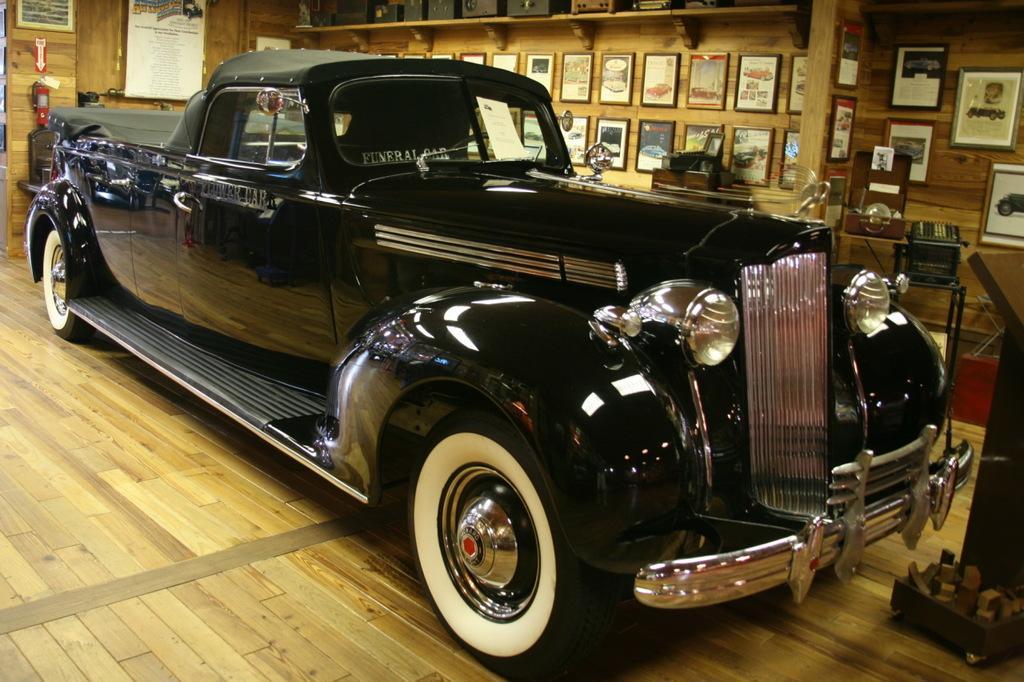Describe this image in one or two sentences. In this image I can see car which is in black color. Background I can see few frames attached to the wooden wall and the wall is in brown color. 